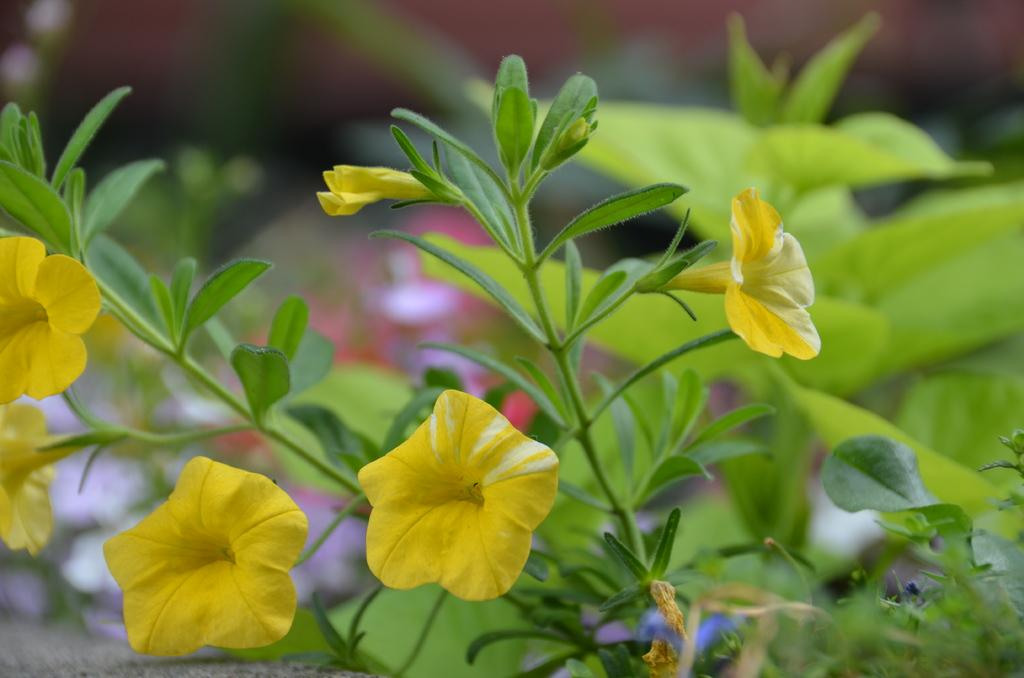What celestial bodies are depicted in the image? There are planets in the image. What type of flora can be seen in the image? There are yellow color flowers in the front of the image. How would you describe the background of the image? The background of the image is blurry. What type of doll is being used for learning in the image? There is no doll or learning activity present in the image; it features planets and yellow flowers. 